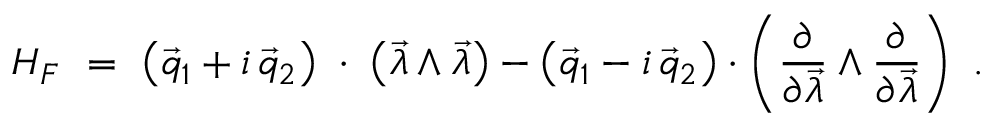<formula> <loc_0><loc_0><loc_500><loc_500>H _ { F } \ = \ \left ( \vec { q } _ { 1 } + i \, \vec { q } _ { 2 } \right ) \, \cdot \, \left ( \vec { \lambda } \wedge \vec { \lambda } \right ) - \left ( \vec { q } _ { 1 } - i \, \vec { q } _ { 2 } \right ) \cdot \left ( \frac { \partial } { \partial \vec { \lambda } } \wedge \frac { \partial } { \partial \vec { \lambda } } \right ) \ .</formula> 